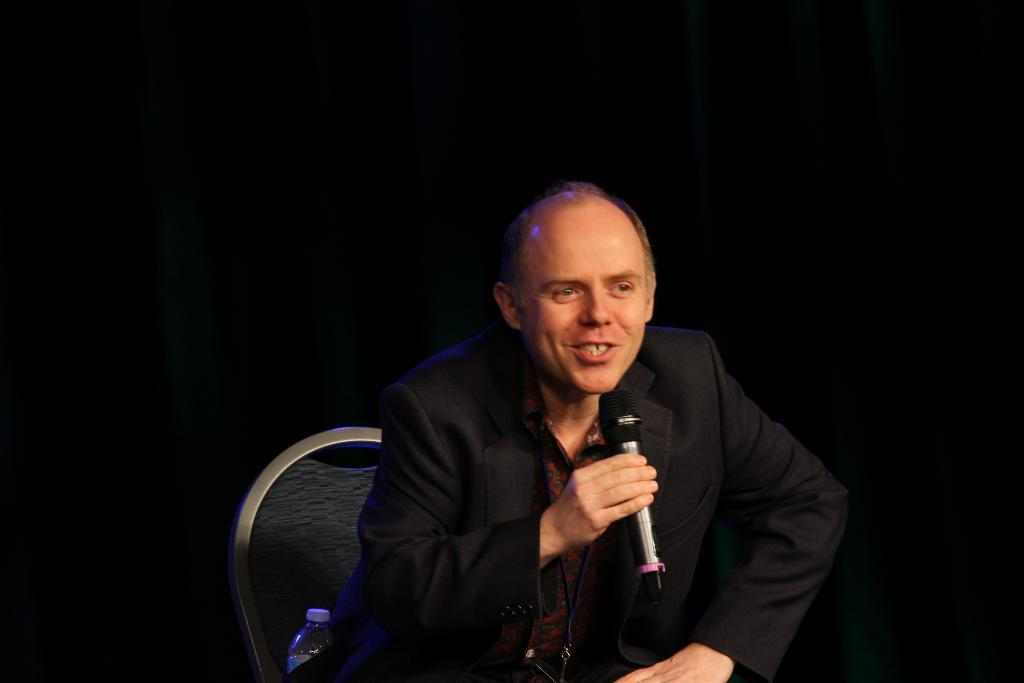Who is present in the image? There is a person in the image. What is the person doing in the image? The person is sitting and talking. What object is the person holding in the image? The person is holding a microphone. Is there any other object visible in the image? Yes, there is a water bottle in the image. What happened in the garden after the person finished talking in the image? There is no garden or aftermath of the person's talking depicted in the image. 